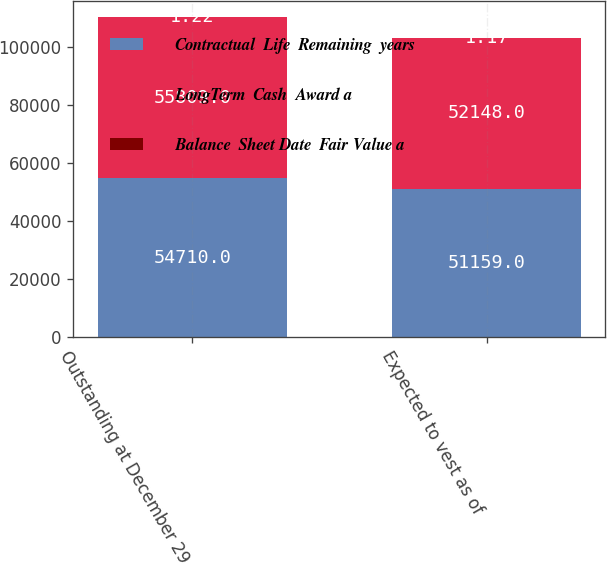Convert chart to OTSL. <chart><loc_0><loc_0><loc_500><loc_500><stacked_bar_chart><ecel><fcel>Outstanding at December 29<fcel>Expected to vest as of<nl><fcel>Contractual  Life  Remaining  years<fcel>54710<fcel>51159<nl><fcel>LongTerm  Cash  Award a<fcel>55809<fcel>52148<nl><fcel>Balance  Sheet Date  Fair Value a<fcel>1.22<fcel>1.17<nl></chart> 